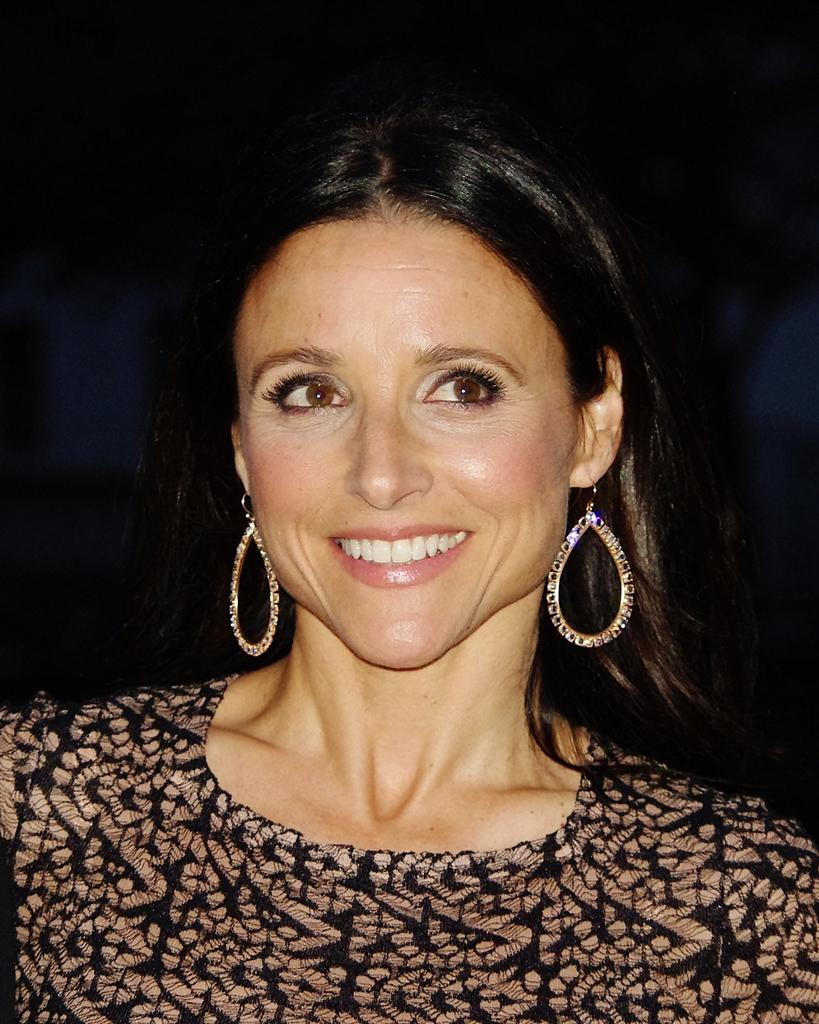Who or what is the main subject of the image? There is a person in the image. What is the person wearing in the image? The person is wearing a black and gold color dress and gold color earrings. What caption is written on the person's dress in the image? There is no caption written on the person's dress in the image. What type of haircut does the person have in the image? The provided facts do not mention the person's haircut, so it cannot be determined from the image. 